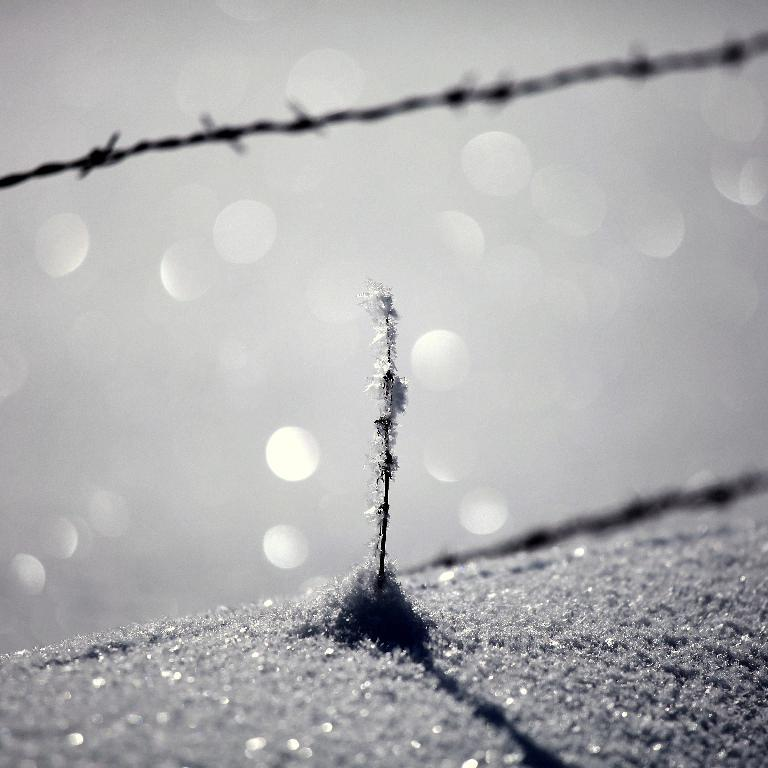What is the color scheme of the image? The image is black and white. What type of terrain is visible in the image? There is sand in the bottom of the image. What kind of vegetation is present on the sand? There is a plant on the sand. What is located at the top of the image? There is a barbed wire on the top of the image. What direction is the quill pointing in the image? There is no quill present in the image. What type of metal is used to make the barbed wire in the image? The image is black and white, so it is not possible to determine the type of metal used for the barbed wire. 